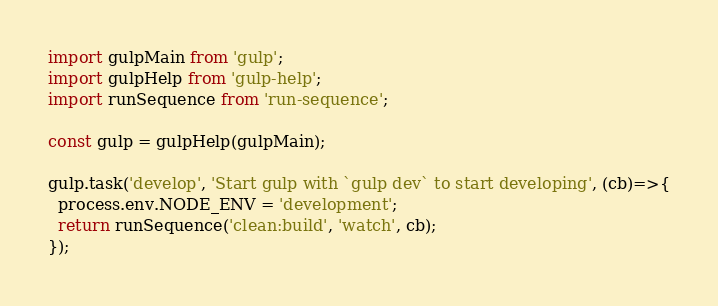Convert code to text. <code><loc_0><loc_0><loc_500><loc_500><_JavaScript_>import gulpMain from 'gulp';
import gulpHelp from 'gulp-help';
import runSequence from 'run-sequence';

const gulp = gulpHelp(gulpMain);

gulp.task('develop', 'Start gulp with `gulp dev` to start developing', (cb)=>{
  process.env.NODE_ENV = 'development';
  return runSequence('clean:build', 'watch', cb);
});</code> 